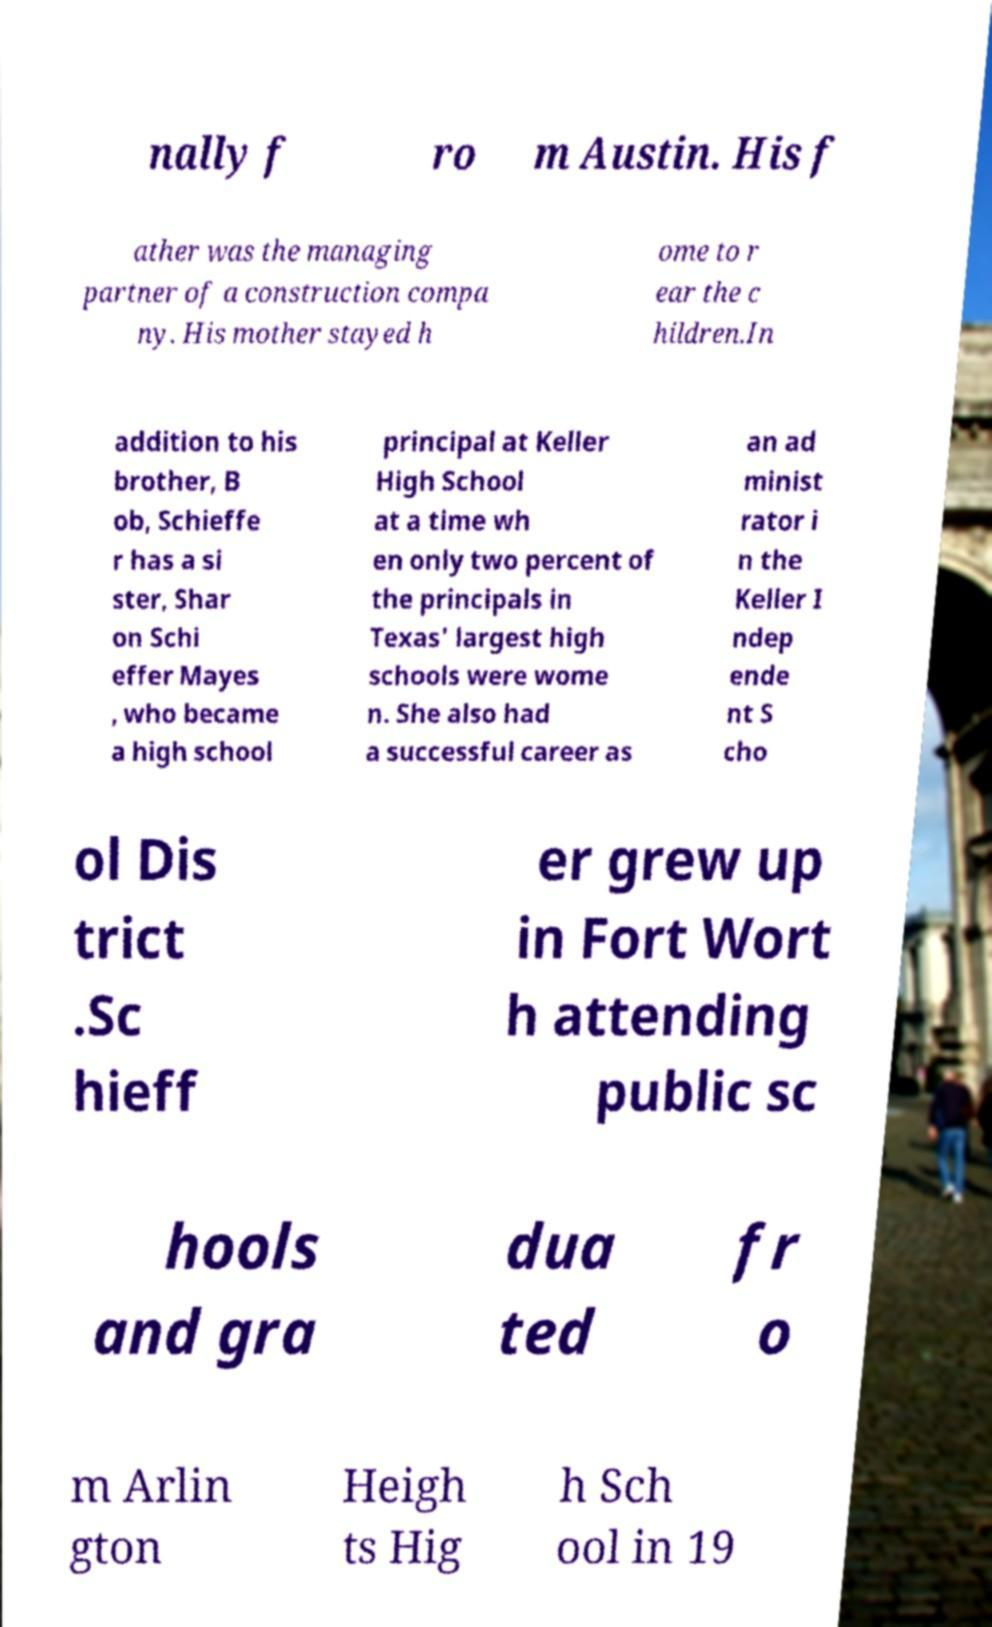Please read and relay the text visible in this image. What does it say? nally f ro m Austin. His f ather was the managing partner of a construction compa ny. His mother stayed h ome to r ear the c hildren.In addition to his brother, B ob, Schieffe r has a si ster, Shar on Schi effer Mayes , who became a high school principal at Keller High School at a time wh en only two percent of the principals in Texas' largest high schools were wome n. She also had a successful career as an ad minist rator i n the Keller I ndep ende nt S cho ol Dis trict .Sc hieff er grew up in Fort Wort h attending public sc hools and gra dua ted fr o m Arlin gton Heigh ts Hig h Sch ool in 19 